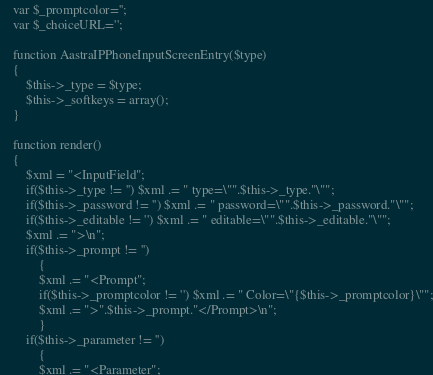<code> <loc_0><loc_0><loc_500><loc_500><_PHP_>	var $_promptcolor='';
	var $_choiceURL='';

	function AastraIPPhoneInputScreenEntry($type)
	{
		$this->_type = $type;
		$this->_softkeys = array();
	}
	
	function render()
	{
		$xml = "<InputField";
		if($this->_type != '') $xml .= " type=\"".$this->_type."\"";
		if($this->_password != '') $xml .= " password=\"".$this->_password."\"";
		if($this->_editable != '') $xml .= " editable=\"".$this->_editable."\"";
		$xml .= ">\n";
		if($this->_prompt != '') 
			{
			$xml .= "<Prompt";
			if($this->_promptcolor != '') $xml .= " Color=\"{$this->_promptcolor}\"";
			$xml .= ">".$this->_prompt."</Prompt>\n";
			}
		if($this->_parameter != '') 
			{
			$xml .= "<Parameter";</code> 